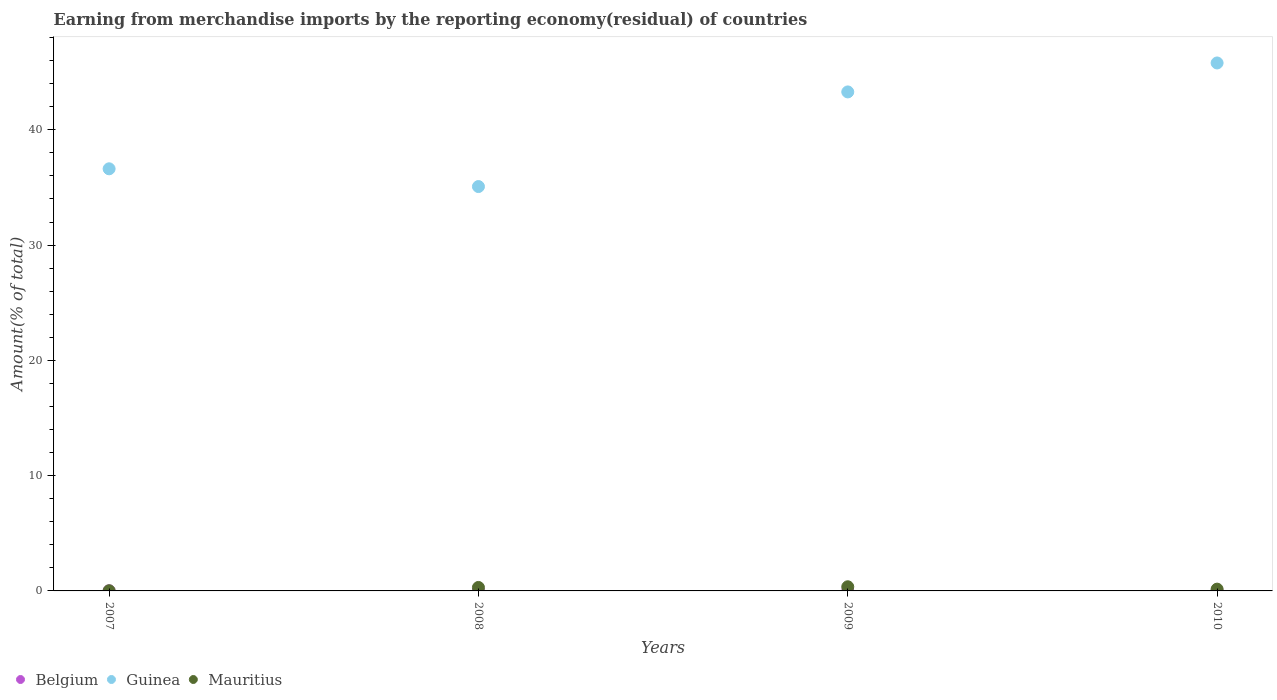Is the number of dotlines equal to the number of legend labels?
Ensure brevity in your answer.  Yes. What is the percentage of amount earned from merchandise imports in Mauritius in 2009?
Provide a succinct answer. 0.36. Across all years, what is the maximum percentage of amount earned from merchandise imports in Guinea?
Your answer should be very brief. 45.8. Across all years, what is the minimum percentage of amount earned from merchandise imports in Guinea?
Offer a terse response. 35.08. What is the total percentage of amount earned from merchandise imports in Guinea in the graph?
Offer a terse response. 160.78. What is the difference between the percentage of amount earned from merchandise imports in Mauritius in 2008 and that in 2009?
Your response must be concise. -0.06. What is the difference between the percentage of amount earned from merchandise imports in Mauritius in 2010 and the percentage of amount earned from merchandise imports in Belgium in 2008?
Offer a terse response. 0.13. What is the average percentage of amount earned from merchandise imports in Mauritius per year?
Your answer should be very brief. 0.21. In the year 2007, what is the difference between the percentage of amount earned from merchandise imports in Belgium and percentage of amount earned from merchandise imports in Guinea?
Make the answer very short. -36.61. In how many years, is the percentage of amount earned from merchandise imports in Mauritius greater than 16 %?
Provide a short and direct response. 0. What is the ratio of the percentage of amount earned from merchandise imports in Guinea in 2007 to that in 2008?
Offer a terse response. 1.04. What is the difference between the highest and the second highest percentage of amount earned from merchandise imports in Belgium?
Provide a short and direct response. 0.01. What is the difference between the highest and the lowest percentage of amount earned from merchandise imports in Mauritius?
Provide a succinct answer. 0.35. Does the percentage of amount earned from merchandise imports in Belgium monotonically increase over the years?
Your response must be concise. No. Is the percentage of amount earned from merchandise imports in Belgium strictly less than the percentage of amount earned from merchandise imports in Mauritius over the years?
Give a very brief answer. Yes. How many dotlines are there?
Make the answer very short. 3. Does the graph contain grids?
Your answer should be very brief. No. Where does the legend appear in the graph?
Offer a very short reply. Bottom left. How many legend labels are there?
Offer a terse response. 3. What is the title of the graph?
Provide a succinct answer. Earning from merchandise imports by the reporting economy(residual) of countries. What is the label or title of the X-axis?
Provide a succinct answer. Years. What is the label or title of the Y-axis?
Keep it short and to the point. Amount(% of total). What is the Amount(% of total) of Belgium in 2007?
Your answer should be compact. 0.01. What is the Amount(% of total) in Guinea in 2007?
Your answer should be very brief. 36.62. What is the Amount(% of total) of Mauritius in 2007?
Your answer should be compact. 0.01. What is the Amount(% of total) in Belgium in 2008?
Offer a terse response. 0.03. What is the Amount(% of total) of Guinea in 2008?
Give a very brief answer. 35.08. What is the Amount(% of total) in Mauritius in 2008?
Give a very brief answer. 0.3. What is the Amount(% of total) of Belgium in 2009?
Make the answer very short. 0.02. What is the Amount(% of total) of Guinea in 2009?
Your answer should be compact. 43.29. What is the Amount(% of total) in Mauritius in 2009?
Your response must be concise. 0.36. What is the Amount(% of total) of Belgium in 2010?
Make the answer very short. 0.01. What is the Amount(% of total) in Guinea in 2010?
Offer a terse response. 45.8. What is the Amount(% of total) in Mauritius in 2010?
Give a very brief answer. 0.15. Across all years, what is the maximum Amount(% of total) of Belgium?
Provide a succinct answer. 0.03. Across all years, what is the maximum Amount(% of total) of Guinea?
Your answer should be compact. 45.8. Across all years, what is the maximum Amount(% of total) of Mauritius?
Your answer should be very brief. 0.36. Across all years, what is the minimum Amount(% of total) of Belgium?
Make the answer very short. 0.01. Across all years, what is the minimum Amount(% of total) of Guinea?
Offer a terse response. 35.08. Across all years, what is the minimum Amount(% of total) in Mauritius?
Provide a short and direct response. 0.01. What is the total Amount(% of total) of Belgium in the graph?
Offer a terse response. 0.07. What is the total Amount(% of total) of Guinea in the graph?
Your response must be concise. 160.78. What is the total Amount(% of total) of Mauritius in the graph?
Offer a very short reply. 0.83. What is the difference between the Amount(% of total) in Belgium in 2007 and that in 2008?
Your response must be concise. -0.02. What is the difference between the Amount(% of total) in Guinea in 2007 and that in 2008?
Your response must be concise. 1.54. What is the difference between the Amount(% of total) in Mauritius in 2007 and that in 2008?
Give a very brief answer. -0.29. What is the difference between the Amount(% of total) in Belgium in 2007 and that in 2009?
Give a very brief answer. -0.01. What is the difference between the Amount(% of total) of Guinea in 2007 and that in 2009?
Your answer should be very brief. -6.67. What is the difference between the Amount(% of total) of Mauritius in 2007 and that in 2009?
Provide a short and direct response. -0.35. What is the difference between the Amount(% of total) in Belgium in 2007 and that in 2010?
Offer a very short reply. -0. What is the difference between the Amount(% of total) in Guinea in 2007 and that in 2010?
Provide a short and direct response. -9.18. What is the difference between the Amount(% of total) in Mauritius in 2007 and that in 2010?
Provide a short and direct response. -0.14. What is the difference between the Amount(% of total) in Belgium in 2008 and that in 2009?
Keep it short and to the point. 0.01. What is the difference between the Amount(% of total) in Guinea in 2008 and that in 2009?
Make the answer very short. -8.21. What is the difference between the Amount(% of total) of Mauritius in 2008 and that in 2009?
Provide a succinct answer. -0.06. What is the difference between the Amount(% of total) in Belgium in 2008 and that in 2010?
Your answer should be very brief. 0.02. What is the difference between the Amount(% of total) of Guinea in 2008 and that in 2010?
Offer a very short reply. -10.72. What is the difference between the Amount(% of total) of Mauritius in 2008 and that in 2010?
Provide a short and direct response. 0.15. What is the difference between the Amount(% of total) of Belgium in 2009 and that in 2010?
Keep it short and to the point. 0. What is the difference between the Amount(% of total) of Guinea in 2009 and that in 2010?
Offer a terse response. -2.51. What is the difference between the Amount(% of total) in Mauritius in 2009 and that in 2010?
Your answer should be very brief. 0.2. What is the difference between the Amount(% of total) in Belgium in 2007 and the Amount(% of total) in Guinea in 2008?
Keep it short and to the point. -35.07. What is the difference between the Amount(% of total) of Belgium in 2007 and the Amount(% of total) of Mauritius in 2008?
Your response must be concise. -0.29. What is the difference between the Amount(% of total) of Guinea in 2007 and the Amount(% of total) of Mauritius in 2008?
Provide a succinct answer. 36.32. What is the difference between the Amount(% of total) of Belgium in 2007 and the Amount(% of total) of Guinea in 2009?
Your answer should be very brief. -43.28. What is the difference between the Amount(% of total) of Belgium in 2007 and the Amount(% of total) of Mauritius in 2009?
Give a very brief answer. -0.35. What is the difference between the Amount(% of total) in Guinea in 2007 and the Amount(% of total) in Mauritius in 2009?
Your answer should be very brief. 36.26. What is the difference between the Amount(% of total) in Belgium in 2007 and the Amount(% of total) in Guinea in 2010?
Offer a terse response. -45.79. What is the difference between the Amount(% of total) in Belgium in 2007 and the Amount(% of total) in Mauritius in 2010?
Ensure brevity in your answer.  -0.14. What is the difference between the Amount(% of total) of Guinea in 2007 and the Amount(% of total) of Mauritius in 2010?
Offer a terse response. 36.46. What is the difference between the Amount(% of total) of Belgium in 2008 and the Amount(% of total) of Guinea in 2009?
Provide a succinct answer. -43.26. What is the difference between the Amount(% of total) of Belgium in 2008 and the Amount(% of total) of Mauritius in 2009?
Offer a very short reply. -0.33. What is the difference between the Amount(% of total) in Guinea in 2008 and the Amount(% of total) in Mauritius in 2009?
Your answer should be compact. 34.72. What is the difference between the Amount(% of total) of Belgium in 2008 and the Amount(% of total) of Guinea in 2010?
Provide a succinct answer. -45.77. What is the difference between the Amount(% of total) in Belgium in 2008 and the Amount(% of total) in Mauritius in 2010?
Your answer should be compact. -0.13. What is the difference between the Amount(% of total) in Guinea in 2008 and the Amount(% of total) in Mauritius in 2010?
Ensure brevity in your answer.  34.92. What is the difference between the Amount(% of total) in Belgium in 2009 and the Amount(% of total) in Guinea in 2010?
Make the answer very short. -45.78. What is the difference between the Amount(% of total) in Belgium in 2009 and the Amount(% of total) in Mauritius in 2010?
Provide a short and direct response. -0.14. What is the difference between the Amount(% of total) of Guinea in 2009 and the Amount(% of total) of Mauritius in 2010?
Your response must be concise. 43.13. What is the average Amount(% of total) of Belgium per year?
Provide a short and direct response. 0.02. What is the average Amount(% of total) of Guinea per year?
Your response must be concise. 40.19. What is the average Amount(% of total) of Mauritius per year?
Offer a terse response. 0.21. In the year 2007, what is the difference between the Amount(% of total) in Belgium and Amount(% of total) in Guinea?
Provide a succinct answer. -36.61. In the year 2007, what is the difference between the Amount(% of total) in Belgium and Amount(% of total) in Mauritius?
Provide a succinct answer. -0. In the year 2007, what is the difference between the Amount(% of total) of Guinea and Amount(% of total) of Mauritius?
Your answer should be compact. 36.6. In the year 2008, what is the difference between the Amount(% of total) in Belgium and Amount(% of total) in Guinea?
Provide a short and direct response. -35.05. In the year 2008, what is the difference between the Amount(% of total) in Belgium and Amount(% of total) in Mauritius?
Your answer should be compact. -0.27. In the year 2008, what is the difference between the Amount(% of total) in Guinea and Amount(% of total) in Mauritius?
Ensure brevity in your answer.  34.78. In the year 2009, what is the difference between the Amount(% of total) of Belgium and Amount(% of total) of Guinea?
Provide a succinct answer. -43.27. In the year 2009, what is the difference between the Amount(% of total) of Belgium and Amount(% of total) of Mauritius?
Offer a terse response. -0.34. In the year 2009, what is the difference between the Amount(% of total) of Guinea and Amount(% of total) of Mauritius?
Make the answer very short. 42.93. In the year 2010, what is the difference between the Amount(% of total) of Belgium and Amount(% of total) of Guinea?
Make the answer very short. -45.78. In the year 2010, what is the difference between the Amount(% of total) in Belgium and Amount(% of total) in Mauritius?
Your answer should be very brief. -0.14. In the year 2010, what is the difference between the Amount(% of total) in Guinea and Amount(% of total) in Mauritius?
Keep it short and to the point. 45.64. What is the ratio of the Amount(% of total) of Belgium in 2007 to that in 2008?
Your response must be concise. 0.39. What is the ratio of the Amount(% of total) of Guinea in 2007 to that in 2008?
Your answer should be very brief. 1.04. What is the ratio of the Amount(% of total) of Mauritius in 2007 to that in 2008?
Your answer should be very brief. 0.05. What is the ratio of the Amount(% of total) in Belgium in 2007 to that in 2009?
Make the answer very short. 0.69. What is the ratio of the Amount(% of total) of Guinea in 2007 to that in 2009?
Provide a short and direct response. 0.85. What is the ratio of the Amount(% of total) in Mauritius in 2007 to that in 2009?
Your answer should be compact. 0.04. What is the ratio of the Amount(% of total) in Belgium in 2007 to that in 2010?
Keep it short and to the point. 0.83. What is the ratio of the Amount(% of total) of Guinea in 2007 to that in 2010?
Keep it short and to the point. 0.8. What is the ratio of the Amount(% of total) of Mauritius in 2007 to that in 2010?
Offer a terse response. 0.09. What is the ratio of the Amount(% of total) of Belgium in 2008 to that in 2009?
Offer a terse response. 1.75. What is the ratio of the Amount(% of total) in Guinea in 2008 to that in 2009?
Provide a succinct answer. 0.81. What is the ratio of the Amount(% of total) in Mauritius in 2008 to that in 2009?
Your answer should be very brief. 0.84. What is the ratio of the Amount(% of total) in Belgium in 2008 to that in 2010?
Your answer should be compact. 2.13. What is the ratio of the Amount(% of total) of Guinea in 2008 to that in 2010?
Your response must be concise. 0.77. What is the ratio of the Amount(% of total) of Mauritius in 2008 to that in 2010?
Ensure brevity in your answer.  1.95. What is the ratio of the Amount(% of total) of Belgium in 2009 to that in 2010?
Make the answer very short. 1.22. What is the ratio of the Amount(% of total) of Guinea in 2009 to that in 2010?
Your answer should be compact. 0.95. What is the ratio of the Amount(% of total) in Mauritius in 2009 to that in 2010?
Make the answer very short. 2.33. What is the difference between the highest and the second highest Amount(% of total) of Belgium?
Your response must be concise. 0.01. What is the difference between the highest and the second highest Amount(% of total) in Guinea?
Your response must be concise. 2.51. What is the difference between the highest and the second highest Amount(% of total) in Mauritius?
Offer a very short reply. 0.06. What is the difference between the highest and the lowest Amount(% of total) of Belgium?
Your answer should be compact. 0.02. What is the difference between the highest and the lowest Amount(% of total) in Guinea?
Ensure brevity in your answer.  10.72. What is the difference between the highest and the lowest Amount(% of total) in Mauritius?
Provide a succinct answer. 0.35. 